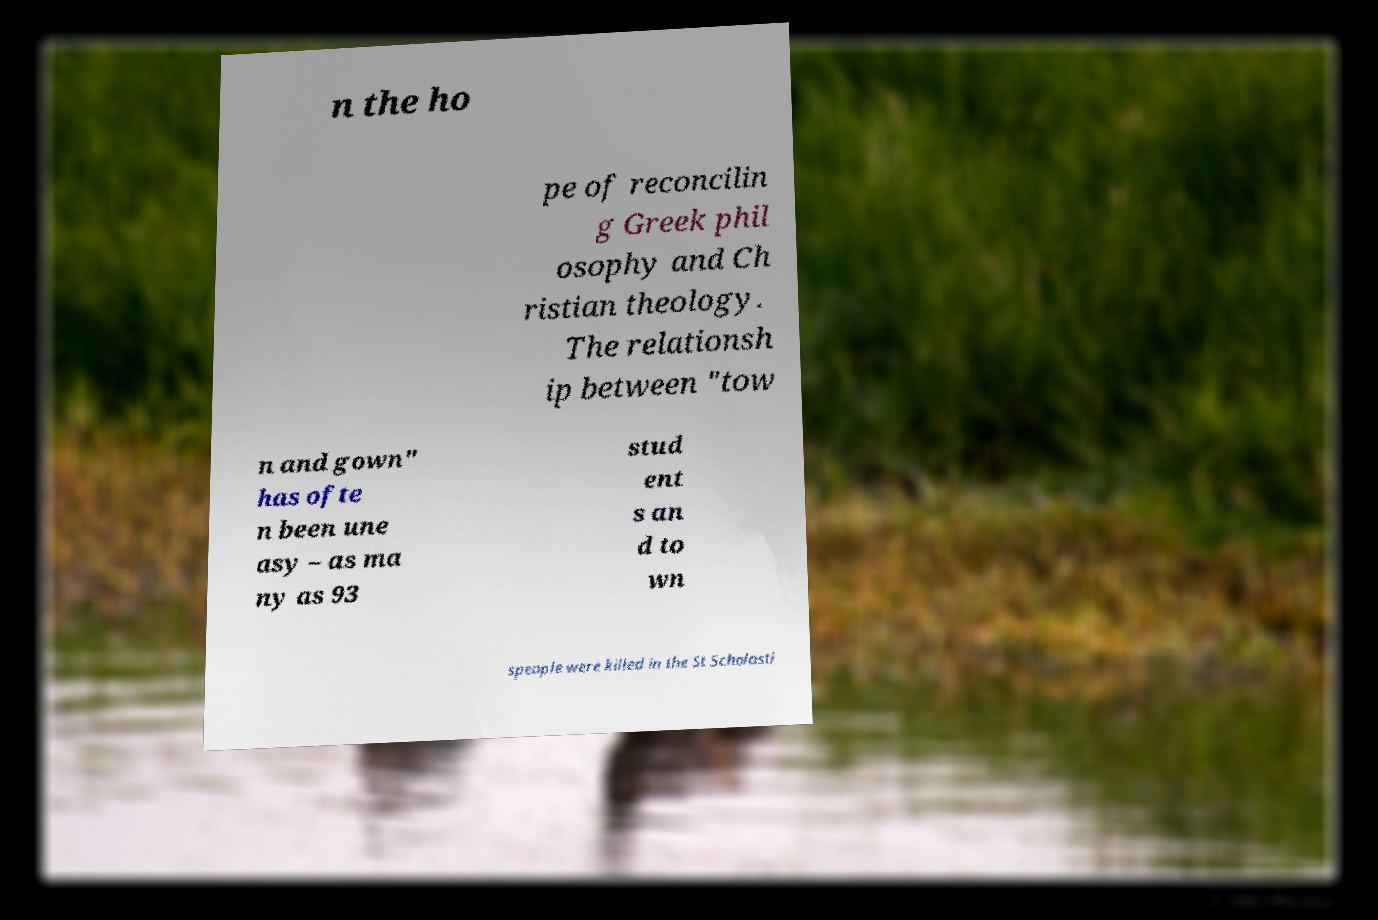What messages or text are displayed in this image? I need them in a readable, typed format. n the ho pe of reconcilin g Greek phil osophy and Ch ristian theology. The relationsh ip between "tow n and gown" has ofte n been une asy – as ma ny as 93 stud ent s an d to wn speople were killed in the St Scholasti 